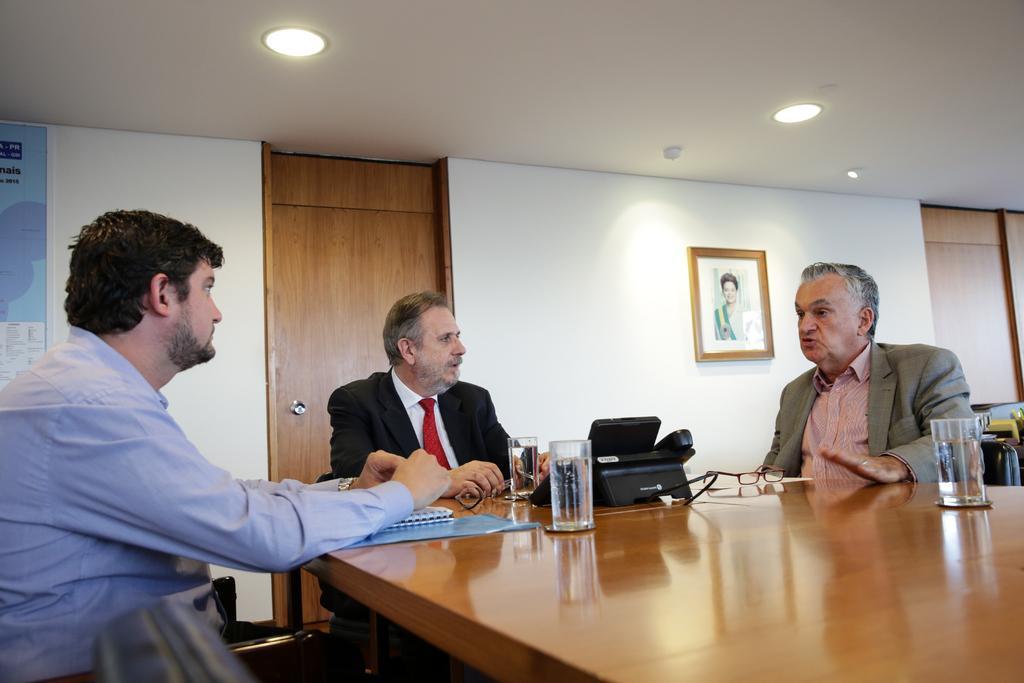In one or two sentences, can you explain what this image depicts? In this picture there are three men who are sitting on the chair. There is a book. There is a glass. There is a spectacle on the table. There is a frame on the wall. There is a poster. There is a door and there is a device. 